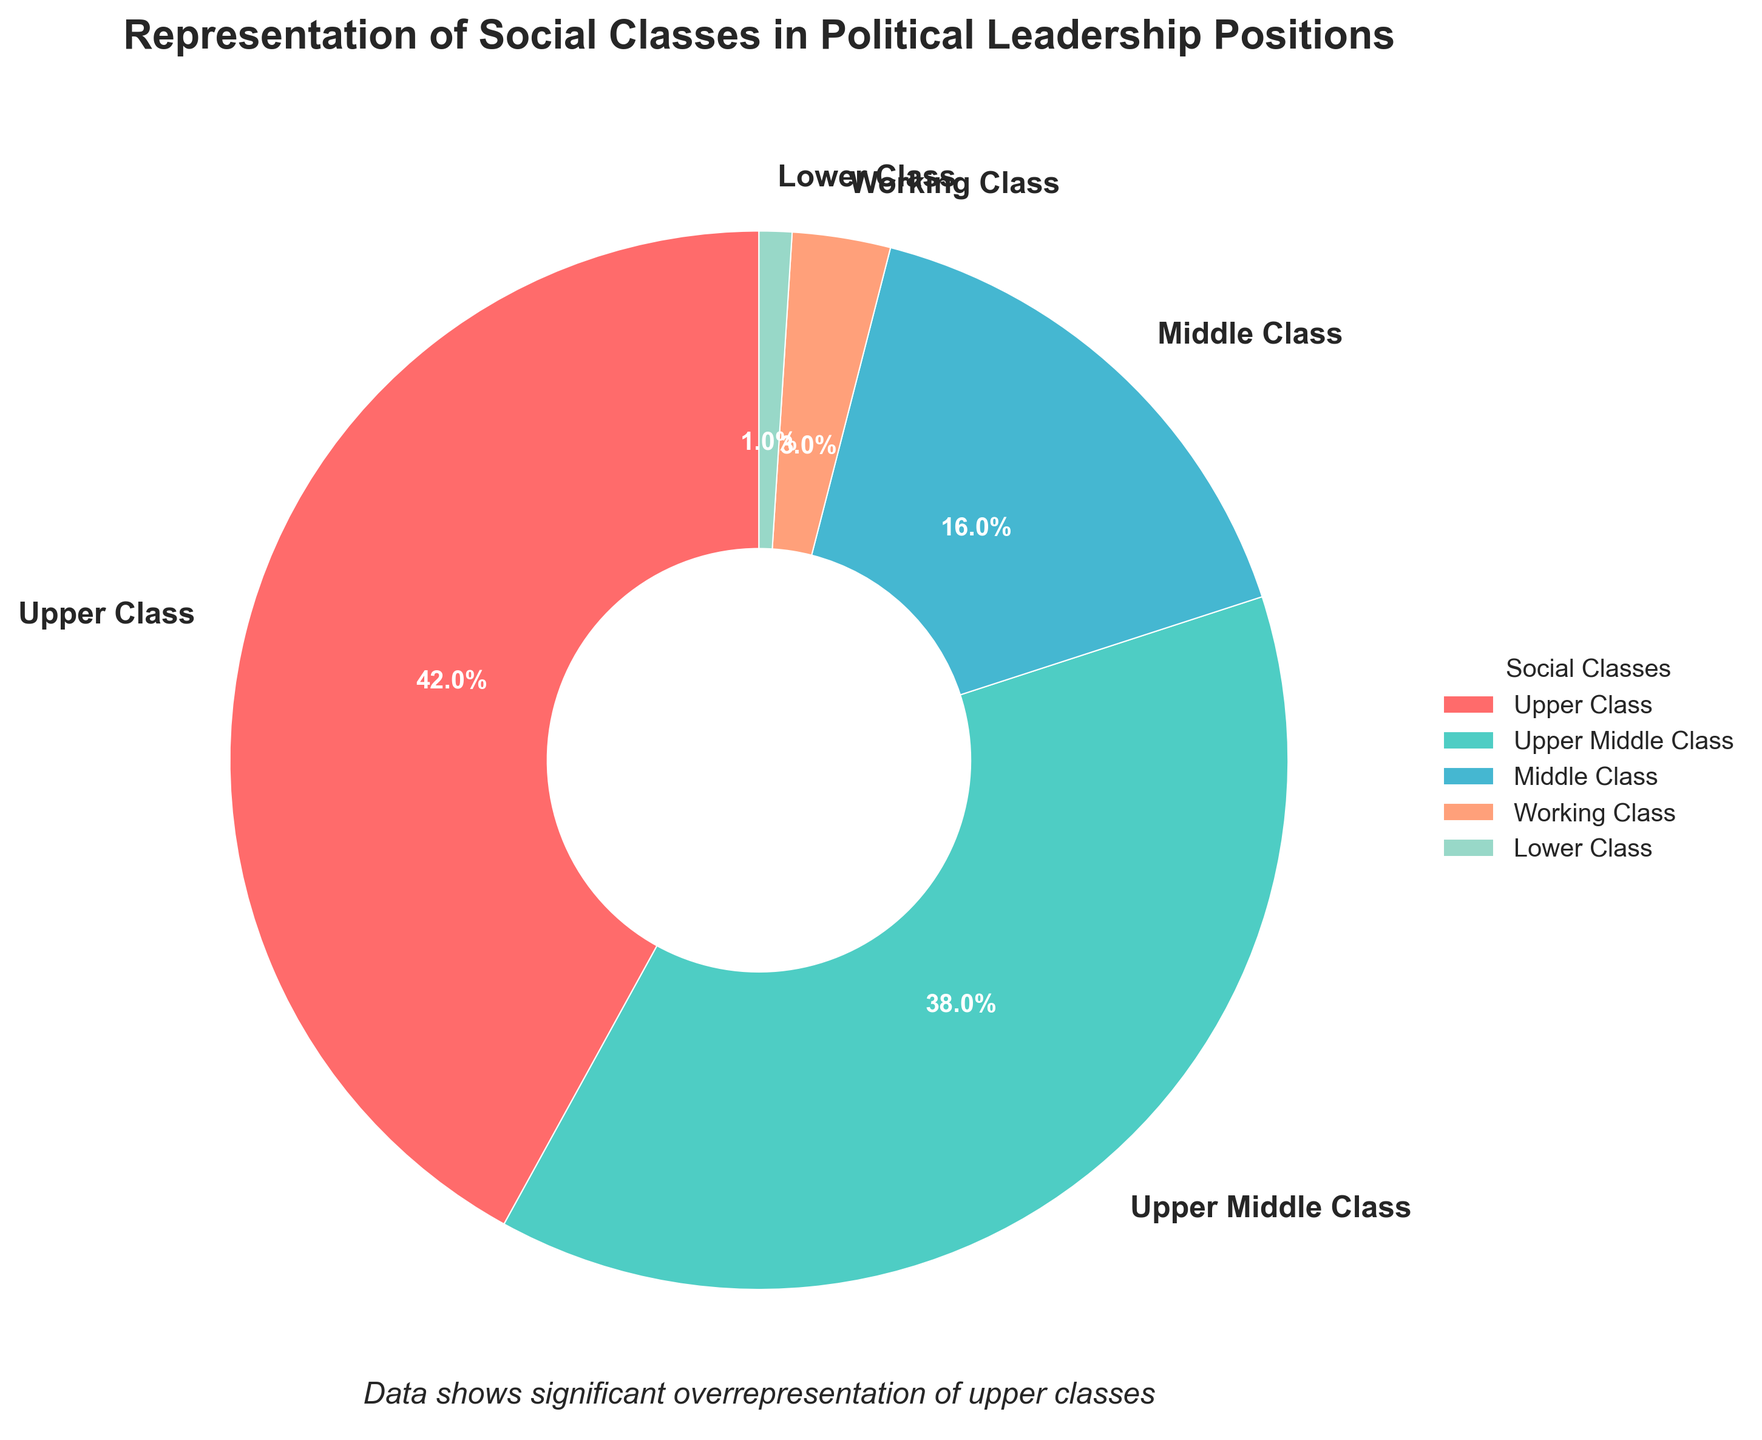What percentage of political leadership positions is occupied by the Upper Middle Class and Middle Class combined? To find the combined percentage, add the percentage of the Upper Middle Class (38%) and the percentage of the Middle Class (16%). The sum is 38 + 16 = 54%.
Answer: 54% Which social class has the least representation in political leadership positions? The pie chart shows that the Lower Class has the smallest wedge, representing just 1% of political leadership positions.
Answer: Lower Class What is the difference in representation between the Upper Class and the Working Class? The percentage representation of the Upper Class is 42%, and the Working Class is 3%. Subtracting these gives 42 - 3 = 39%.
Answer: 39% How does the representation of the Middle Class compare to that of the Working Class? The representation of the Middle Class is 16%, while the Working Class is 3%. Since 16% is greater than 3%, the Middle Class has a higher representation.
Answer: Middle Class has higher representation What is the sum of the percentages for the Working Class and Lower Class? Add the percentages for the Working Class (3%) and Lower Class (1%) to find the sum: 3 + 1 = 4%.
Answer: 4% Which two social classes together account for the majority of political leadership positions? The Upper Class (42%) and Upper Middle Class (38%) together sum up to 42 + 38 = 80%, which is more than 50% and thus constitutes the majority.
Answer: Upper Class and Upper Middle Class What is the average percentage representation for the Middle Class, Working Class, and Lower Class? The percentages are 16%, 3%, and 1%. Adding these gives a total of 16 + 3 + 1 = 20%. There are 3 classes, so divide by 3: 20 / 3 ≈ 6.67%.
Answer: 6.67% In terms of visual attributes, which color represents the Upper Class? The wedge representing the Upper Class is filled with the color red.
Answer: Red What proportion of political leadership positions does the Upper Class occupy relative to the Upper Middle Class? The Upper Class occupies 42% while the Upper Middle Class occupies 38%. The ratio is 42/38, which simplifies to approximately 1.11.
Answer: 1.11 Looking at the subtitle, what does it suggest about the representation in political leadership positions? The subtitle mentions, "Data shows significant overrepresentation of upper classes," indicating that the Upper Class and Upper Middle Class are overrepresented compared to other classes.
Answer: Overrepresentation of upper classes 